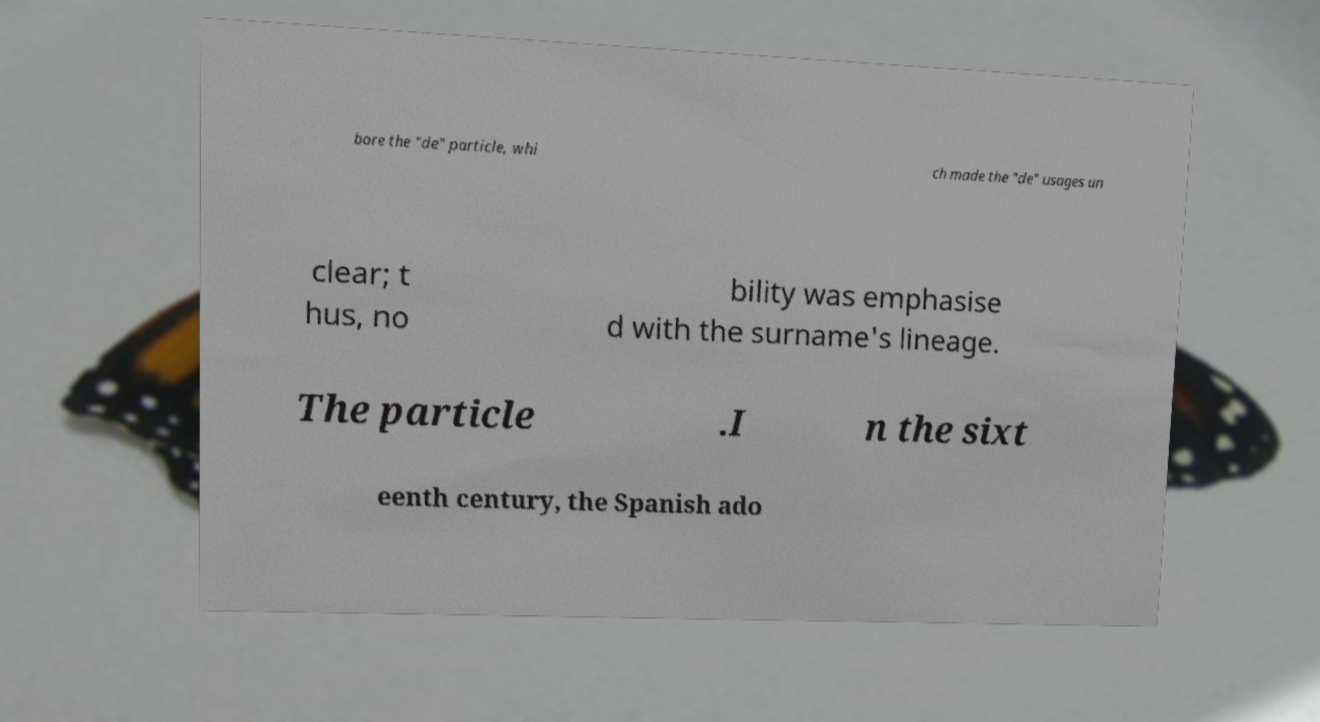Please read and relay the text visible in this image. What does it say? bore the "de" particle, whi ch made the "de" usages un clear; t hus, no bility was emphasise d with the surname's lineage. The particle .I n the sixt eenth century, the Spanish ado 